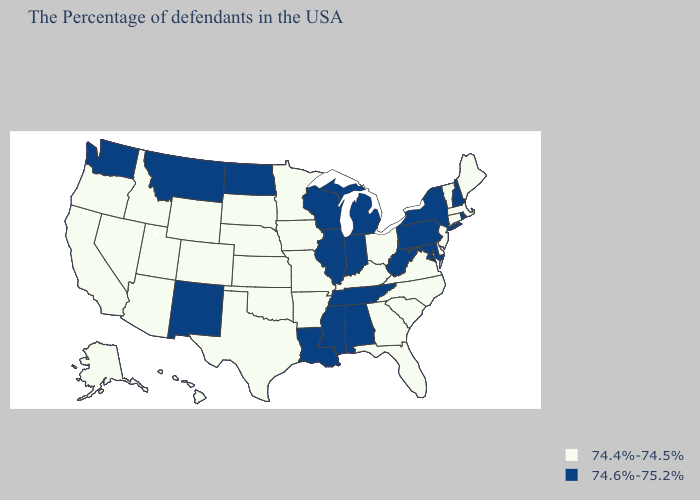Name the states that have a value in the range 74.6%-75.2%?
Give a very brief answer. Rhode Island, New Hampshire, New York, Maryland, Pennsylvania, West Virginia, Michigan, Indiana, Alabama, Tennessee, Wisconsin, Illinois, Mississippi, Louisiana, North Dakota, New Mexico, Montana, Washington. Does Rhode Island have the lowest value in the Northeast?
Give a very brief answer. No. What is the value of Oklahoma?
Give a very brief answer. 74.4%-74.5%. What is the lowest value in states that border Tennessee?
Concise answer only. 74.4%-74.5%. What is the value of Louisiana?
Be succinct. 74.6%-75.2%. Name the states that have a value in the range 74.6%-75.2%?
Short answer required. Rhode Island, New Hampshire, New York, Maryland, Pennsylvania, West Virginia, Michigan, Indiana, Alabama, Tennessee, Wisconsin, Illinois, Mississippi, Louisiana, North Dakota, New Mexico, Montana, Washington. What is the value of South Dakota?
Give a very brief answer. 74.4%-74.5%. How many symbols are there in the legend?
Write a very short answer. 2. What is the value of Connecticut?
Write a very short answer. 74.4%-74.5%. Among the states that border Alabama , does Mississippi have the lowest value?
Keep it brief. No. What is the value of Nebraska?
Keep it brief. 74.4%-74.5%. What is the highest value in the USA?
Concise answer only. 74.6%-75.2%. What is the value of Colorado?
Short answer required. 74.4%-74.5%. Name the states that have a value in the range 74.6%-75.2%?
Quick response, please. Rhode Island, New Hampshire, New York, Maryland, Pennsylvania, West Virginia, Michigan, Indiana, Alabama, Tennessee, Wisconsin, Illinois, Mississippi, Louisiana, North Dakota, New Mexico, Montana, Washington. What is the value of Idaho?
Answer briefly. 74.4%-74.5%. 